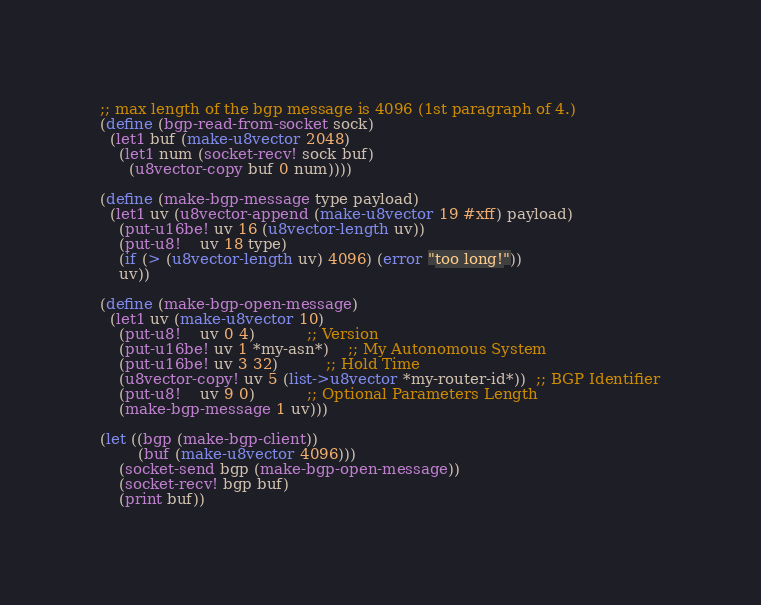Convert code to text. <code><loc_0><loc_0><loc_500><loc_500><_Scheme_>;; max length of the bgp message is 4096 (1st paragraph of 4.)
(define (bgp-read-from-socket sock)
  (let1 buf (make-u8vector 2048)
    (let1 num (socket-recv! sock buf)
      (u8vector-copy buf 0 num))))

(define (make-bgp-message type payload)
  (let1 uv (u8vector-append (make-u8vector 19 #xff) payload)
    (put-u16be! uv 16 (u8vector-length uv))
    (put-u8!    uv 18 type)
    (if (> (u8vector-length uv) 4096) (error "too long!"))
    uv))

(define (make-bgp-open-message)
  (let1 uv (make-u8vector 10)
    (put-u8!    uv 0 4)           ;; Version
    (put-u16be! uv 1 *my-asn*)    ;; My Autonomous System
    (put-u16be! uv 3 32)          ;; Hold Time
    (u8vector-copy! uv 5 (list->u8vector *my-router-id*))  ;; BGP Identifier
    (put-u8!    uv 9 0)           ;; Optional Parameters Length
    (make-bgp-message 1 uv)))

(let ((bgp (make-bgp-client))
	    (buf (make-u8vector 4096)))
	(socket-send bgp (make-bgp-open-message))
	(socket-recv! bgp buf)
	(print buf))
</code> 